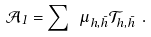Convert formula to latex. <formula><loc_0><loc_0><loc_500><loc_500>\mathcal { A } _ { 1 } = \sum \ \mu _ { h , \bar { h } } \mathcal { T } _ { h , \bar { h } } \ .</formula> 